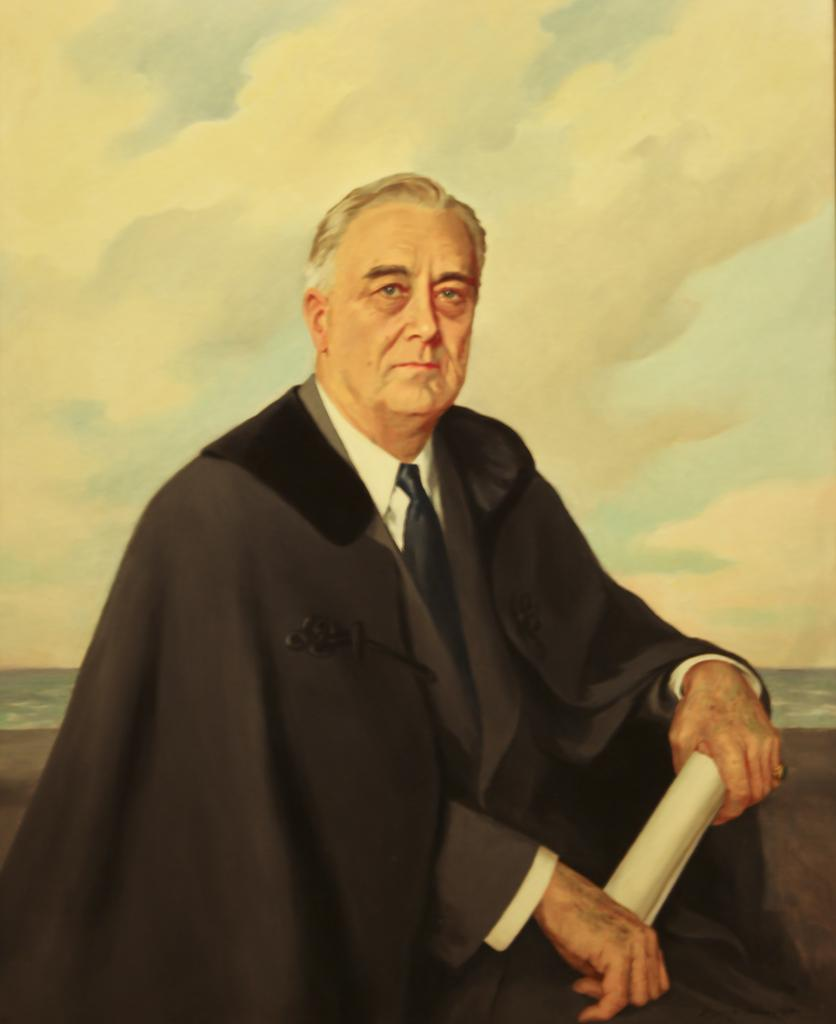What is depicted in the image? There is a painting of a person in the image. What is the person in the painting holding? The person in the painting is holding a paper. What type of government is depicted in the painting? There is no government depicted in the painting; it is a painting of a person holding a paper. How many apples can be seen in the painting? There are no apples present in the painting; it features a person holding a paper. 